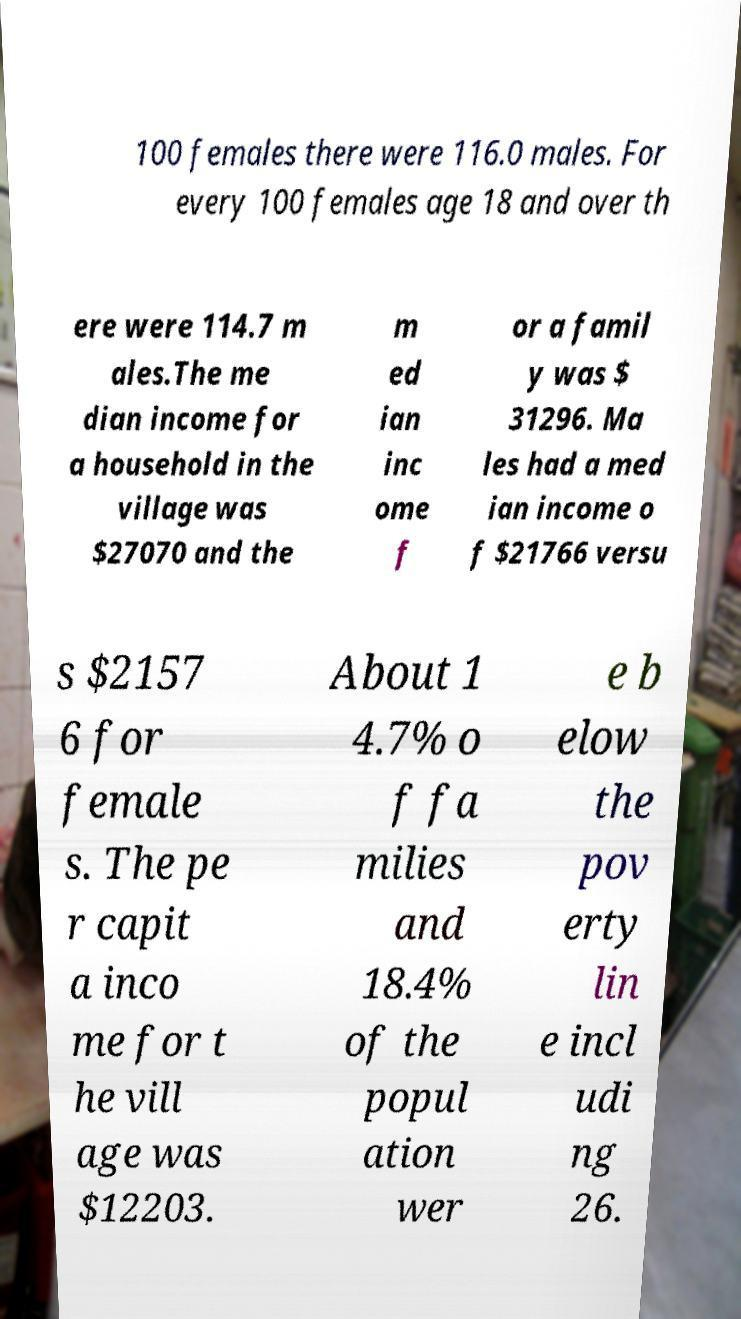There's text embedded in this image that I need extracted. Can you transcribe it verbatim? 100 females there were 116.0 males. For every 100 females age 18 and over th ere were 114.7 m ales.The me dian income for a household in the village was $27070 and the m ed ian inc ome f or a famil y was $ 31296. Ma les had a med ian income o f $21766 versu s $2157 6 for female s. The pe r capit a inco me for t he vill age was $12203. About 1 4.7% o f fa milies and 18.4% of the popul ation wer e b elow the pov erty lin e incl udi ng 26. 